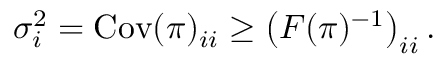Convert formula to latex. <formula><loc_0><loc_0><loc_500><loc_500>\begin{array} { r } { \sigma _ { i } ^ { 2 } = C o v ( { \boldsymbol \pi } ) _ { i i } \geq \left ( F ( { \boldsymbol \pi } ) ^ { - 1 } \right ) _ { i i } . } \end{array}</formula> 